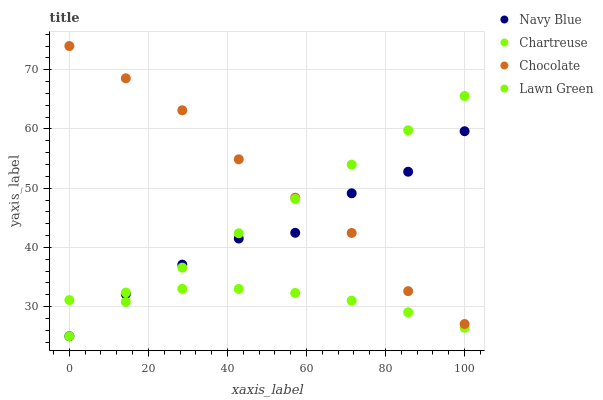Does Chartreuse have the minimum area under the curve?
Answer yes or no. Yes. Does Chocolate have the maximum area under the curve?
Answer yes or no. Yes. Does Lawn Green have the minimum area under the curve?
Answer yes or no. No. Does Lawn Green have the maximum area under the curve?
Answer yes or no. No. Is Lawn Green the smoothest?
Answer yes or no. Yes. Is Navy Blue the roughest?
Answer yes or no. Yes. Is Chartreuse the smoothest?
Answer yes or no. No. Is Chartreuse the roughest?
Answer yes or no. No. Does Navy Blue have the lowest value?
Answer yes or no. Yes. Does Chartreuse have the lowest value?
Answer yes or no. No. Does Chocolate have the highest value?
Answer yes or no. Yes. Does Lawn Green have the highest value?
Answer yes or no. No. Is Chartreuse less than Chocolate?
Answer yes or no. Yes. Is Chocolate greater than Chartreuse?
Answer yes or no. Yes. Does Lawn Green intersect Chartreuse?
Answer yes or no. Yes. Is Lawn Green less than Chartreuse?
Answer yes or no. No. Is Lawn Green greater than Chartreuse?
Answer yes or no. No. Does Chartreuse intersect Chocolate?
Answer yes or no. No. 